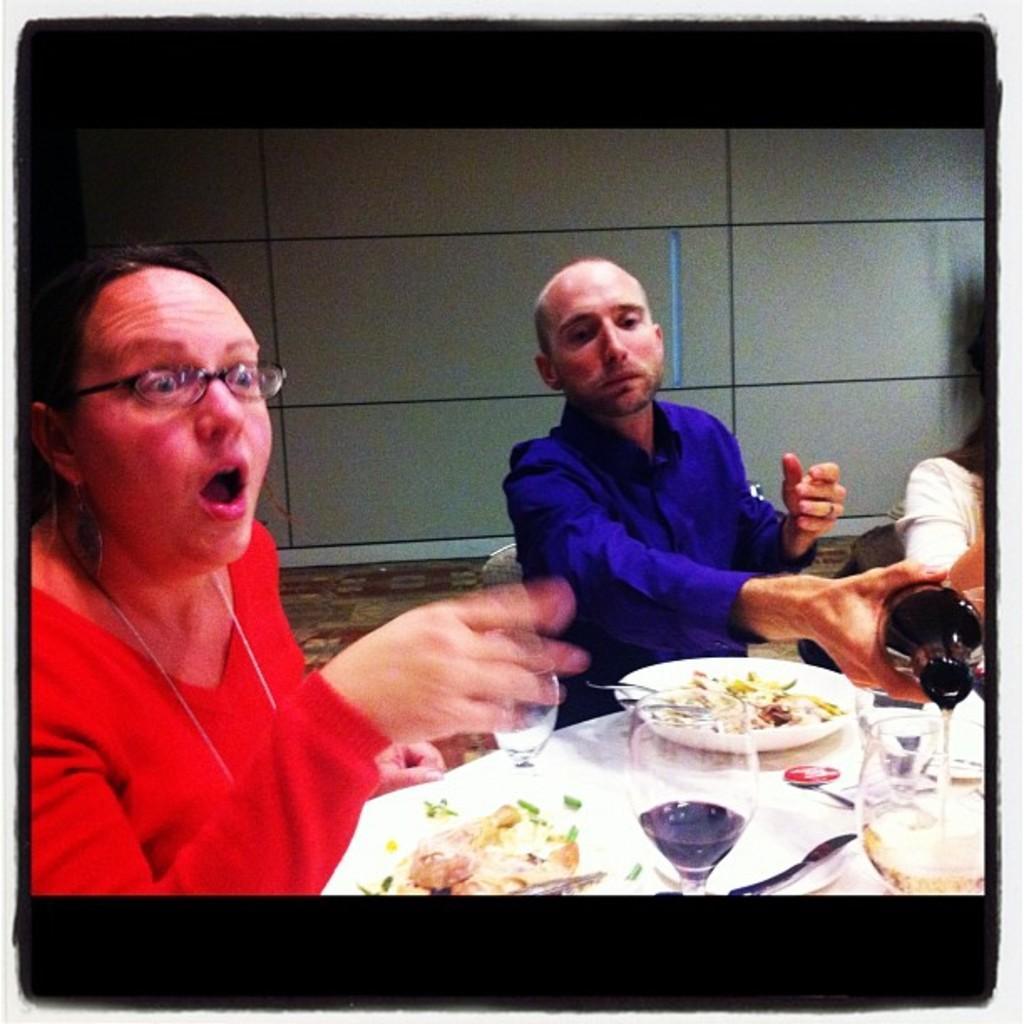How would you summarize this image in a sentence or two? In this image we can see two persons are sitting on the chairs and he is holding a bottle with his hand. There is a table. On the table we can see glasses with drink, plates, and food. In the background we can see floor and wall. On the right side of the image we can see a person who is truncated. 